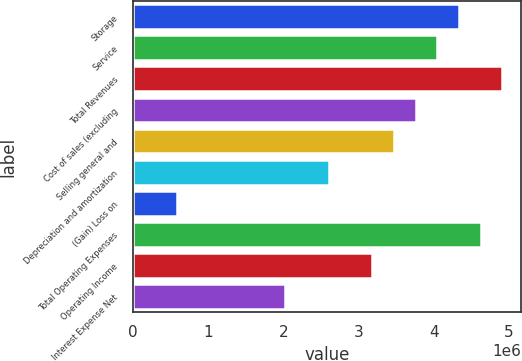Convert chart. <chart><loc_0><loc_0><loc_500><loc_500><bar_chart><fcel>Storage<fcel>Service<fcel>Total Revenues<fcel>Cost of sales (excluding<fcel>Selling general and<fcel>Depreciation and amortization<fcel>(Gain) Loss on<fcel>Total Operating Expenses<fcel>Operating Income<fcel>Interest Expense Net<nl><fcel>4.33607e+06<fcel>4.04733e+06<fcel>4.91356e+06<fcel>3.75858e+06<fcel>3.46984e+06<fcel>2.6036e+06<fcel>582396<fcel>4.62481e+06<fcel>3.18109e+06<fcel>2.02612e+06<nl></chart> 